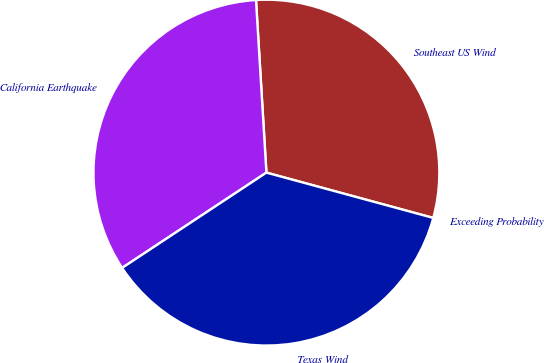Convert chart to OTSL. <chart><loc_0><loc_0><loc_500><loc_500><pie_chart><fcel>Exceeding Probability<fcel>Southeast US Wind<fcel>California Earthquake<fcel>Texas Wind<nl><fcel>0.0%<fcel>30.18%<fcel>33.33%<fcel>36.49%<nl></chart> 